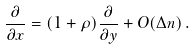Convert formula to latex. <formula><loc_0><loc_0><loc_500><loc_500>\frac { \partial } { \partial x } = ( 1 + \rho ) \frac { \partial } { \partial y } + O ( \Delta n ) \, .</formula> 